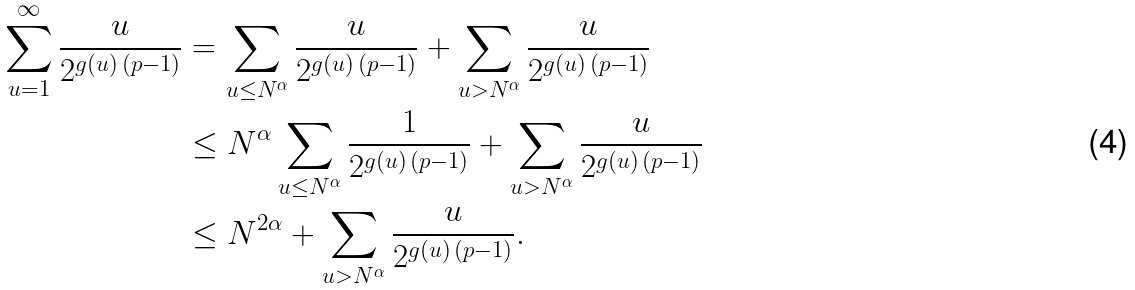<formula> <loc_0><loc_0><loc_500><loc_500>\sum _ { u = 1 } ^ { \infty } \frac { u } { 2 ^ { g ( u ) \, ( p - 1 ) } } & = \sum _ { u \leq N ^ { \alpha } } \frac { u } { 2 ^ { g ( u ) \, ( p - 1 ) } } + \sum _ { u > N ^ { \alpha } } \frac { u } { 2 ^ { g ( u ) \, ( p - 1 ) } } \\ & \leq N ^ { \alpha } \sum _ { u \leq N ^ { \alpha } } \frac { 1 } { 2 ^ { g ( u ) \, ( p - 1 ) } } + \sum _ { u > N ^ { \alpha } } \frac { u } { 2 ^ { g ( u ) \, ( p - 1 ) } } \\ & \leq N ^ { 2 \alpha } + \sum _ { u > N ^ { \alpha } } \frac { u } { 2 ^ { g ( u ) \, ( p - 1 ) } } .</formula> 